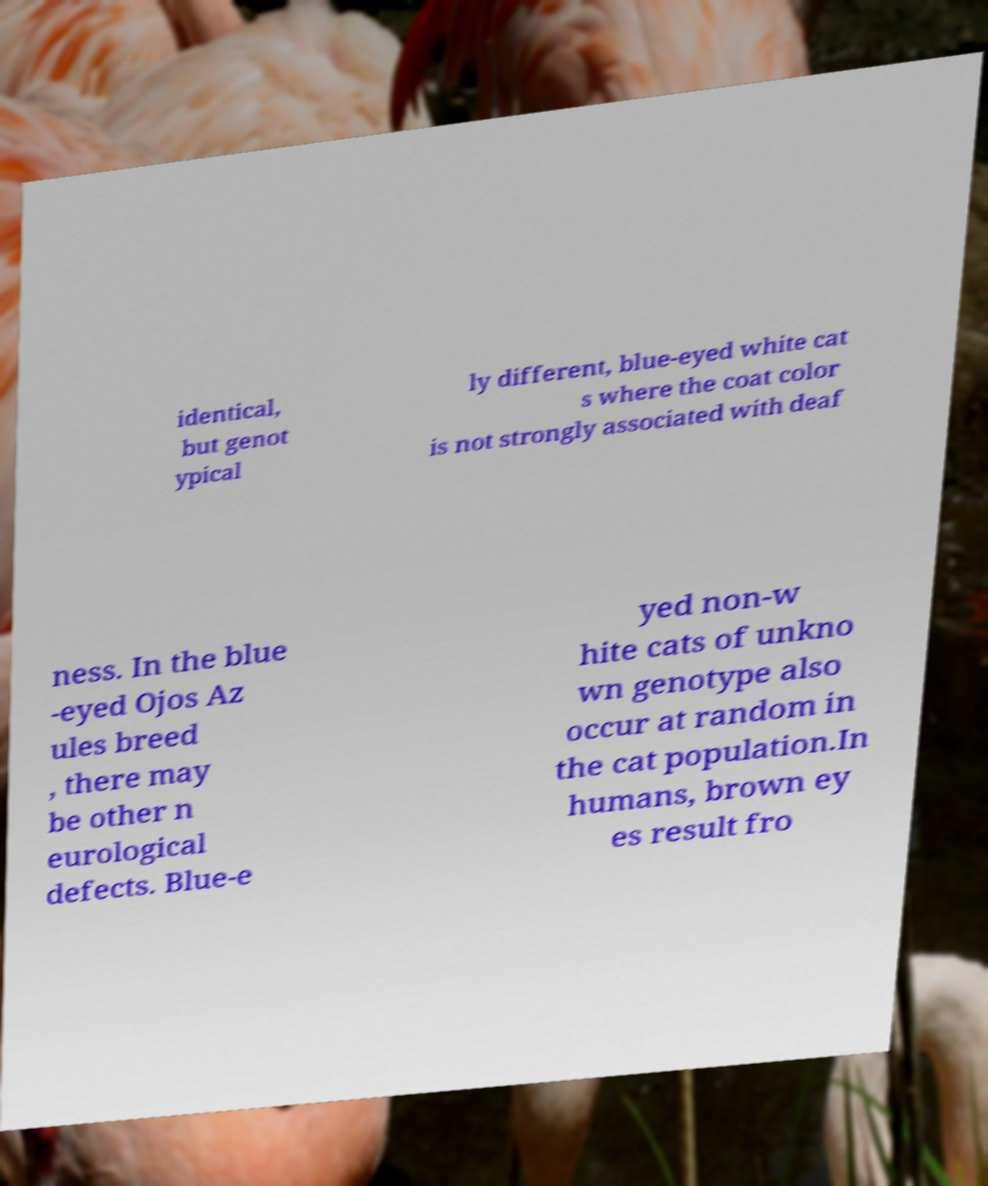I need the written content from this picture converted into text. Can you do that? identical, but genot ypical ly different, blue-eyed white cat s where the coat color is not strongly associated with deaf ness. In the blue -eyed Ojos Az ules breed , there may be other n eurological defects. Blue-e yed non-w hite cats of unkno wn genotype also occur at random in the cat population.In humans, brown ey es result fro 